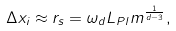<formula> <loc_0><loc_0><loc_500><loc_500>\Delta x _ { i } \approx r _ { s } = \omega _ { d } L _ { P l } m ^ { \frac { 1 } { d - 3 } } ,</formula> 